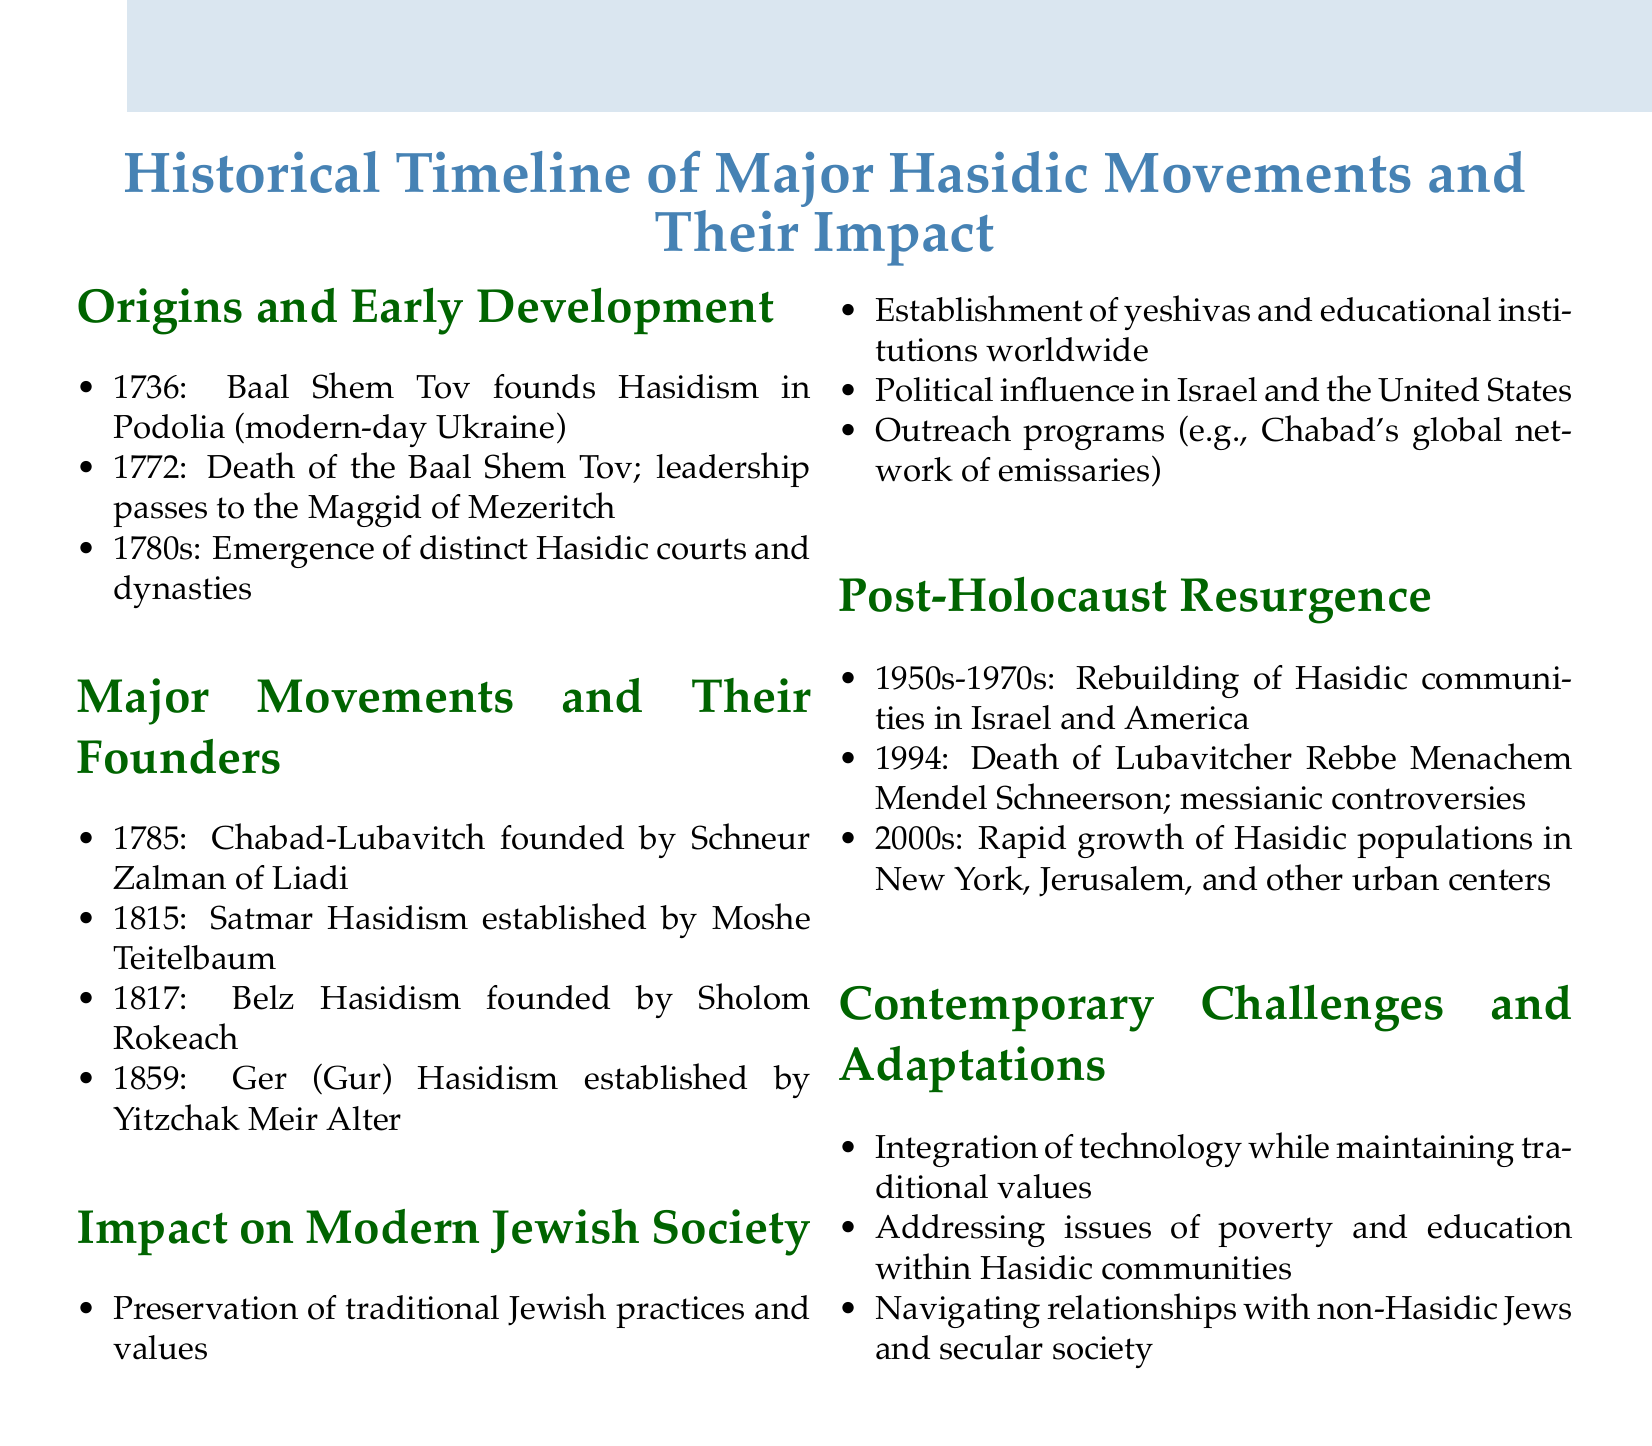What year was Hasidism founded? The document states that the Baal Shem Tov founded Hasidism in 1736.
Answer: 1736 Who established Satmar Hasidism? According to the document, Satmar Hasidism was established by Moshe Teitelbaum.
Answer: Moshe Teitelbaum What is one impact of Hasidic movements on modern Jewish society? The document lists several impacts, one being the establishment of yeshivas and educational institutions worldwide.
Answer: Establishment of yeshivas In what decade did the rebuilding of Hasidic communities occur post-Holocaust? The document indicates that the rebuilding took place during the 1950s to 1970s.
Answer: 1950s-1970s What major controversy arose after the death of Lubavitcher Rebbe Menachem Mendel Schneerson? The document mentions that there were messianic controversies following his death in 1994.
Answer: Messianic controversies What year did the Chabad-Lubavitch movement get founded? The document notes that Chabad-Lubavitch was founded in 1785.
Answer: 1785 What challenge do contemporary Hasidic communities face regarding technology? The document points out that they face integration of technology while maintaining traditional values.
Answer: Integration of technology How did Hasidic movements influence politics? The document states that they have political influence in Israel and the United States.
Answer: Political influence in Israel and the United States 